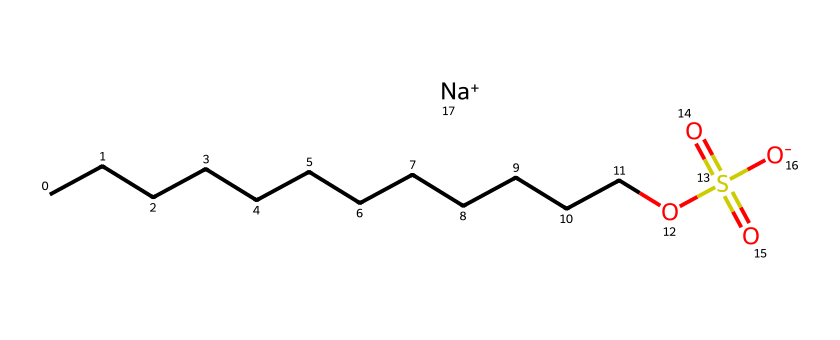What is the molecular formula of sodium lauryl sulfate? The SMILES representation indicates the presence of 12 carbon atoms (from the CCCC... parts), 26 hydrogen atoms (considering the saturation), 1 sulfur atom, and 4 oxygen atoms (from the SO4 group and the sodium ion). Therefore, the molecular formula is C12H25NaO4S.
Answer: C12H25NaO4S How many carbon atoms are present in sodium lauryl sulfate? By analyzing the long hydrocarbon chain (CCCCCCCCCCCC), we can count 12 distinct carbon atoms in the chain, resulting in a total of 12.
Answer: 12 What type of chemical structure is sodium lauryl sulfate classified as? Sodium lauryl sulfate contains both hydrophobic (the carbon chain) and hydrophilic (the sulfonate group) components, which qualify it as an anionic surfactant.
Answer: anionic surfactant What is the significance of the sodium ion in the structure? The sodium ion (Na+) is crucial for charge balance in the compound and helps in solubilizing the surfactant in water, making it soluble and effective in forming foams.
Answer: charge balance What functional groups are present in sodium lauryl sulfate? The SMILES representation reveals a sulfonate group (SO4) and indicates that it is a salt due to the presence of Na+. The presence of carbon and sulfur atoms together implies the presence of the sulfonic acid functional group.
Answer: sulfonate group What effect does the long carbon chain have on the properties of sodium lauryl sulfate? The long carbon chain increases the hydrophobic nature of sodium lauryl sulfate, which enhances its ability to reduce surface tension and improve foaming properties in solution.
Answer: increases hydrophobicity 